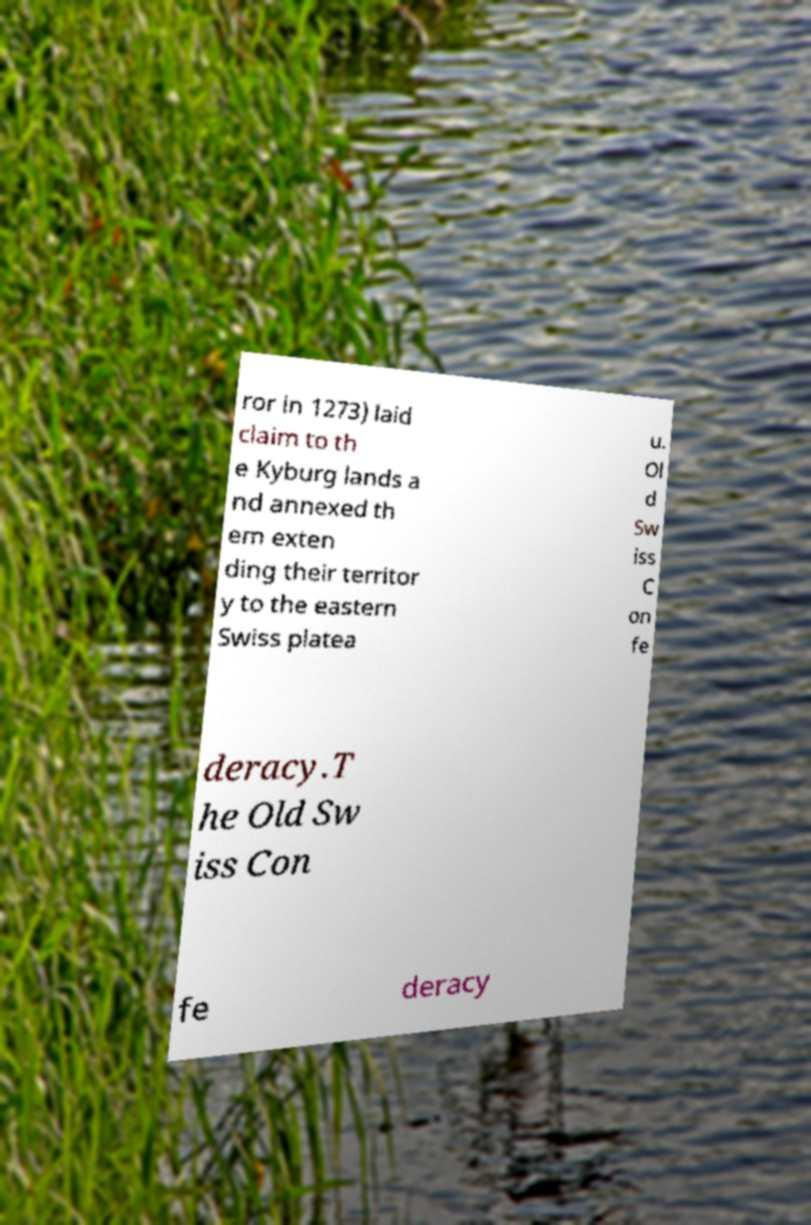For documentation purposes, I need the text within this image transcribed. Could you provide that? ror in 1273) laid claim to th e Kyburg lands a nd annexed th em exten ding their territor y to the eastern Swiss platea u. Ol d Sw iss C on fe deracy.T he Old Sw iss Con fe deracy 